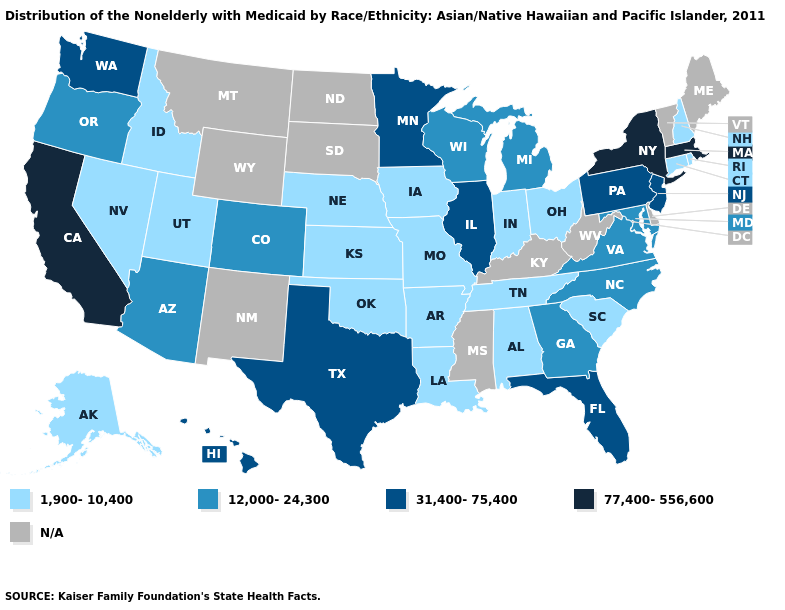Which states have the highest value in the USA?
Write a very short answer. California, Massachusetts, New York. Name the states that have a value in the range 77,400-556,600?
Give a very brief answer. California, Massachusetts, New York. Name the states that have a value in the range 1,900-10,400?
Quick response, please. Alabama, Alaska, Arkansas, Connecticut, Idaho, Indiana, Iowa, Kansas, Louisiana, Missouri, Nebraska, Nevada, New Hampshire, Ohio, Oklahoma, Rhode Island, South Carolina, Tennessee, Utah. What is the lowest value in states that border Georgia?
Answer briefly. 1,900-10,400. Which states hav the highest value in the South?
Keep it brief. Florida, Texas. Among the states that border Indiana , does Ohio have the lowest value?
Quick response, please. Yes. Name the states that have a value in the range 1,900-10,400?
Answer briefly. Alabama, Alaska, Arkansas, Connecticut, Idaho, Indiana, Iowa, Kansas, Louisiana, Missouri, Nebraska, Nevada, New Hampshire, Ohio, Oklahoma, Rhode Island, South Carolina, Tennessee, Utah. What is the value of Wyoming?
Concise answer only. N/A. Does California have the highest value in the USA?
Give a very brief answer. Yes. What is the value of Alaska?
Keep it brief. 1,900-10,400. What is the lowest value in states that border New Mexico?
Quick response, please. 1,900-10,400. What is the lowest value in the USA?
Quick response, please. 1,900-10,400. Among the states that border Oklahoma , does Texas have the highest value?
Concise answer only. Yes. Does the first symbol in the legend represent the smallest category?
Answer briefly. Yes. 